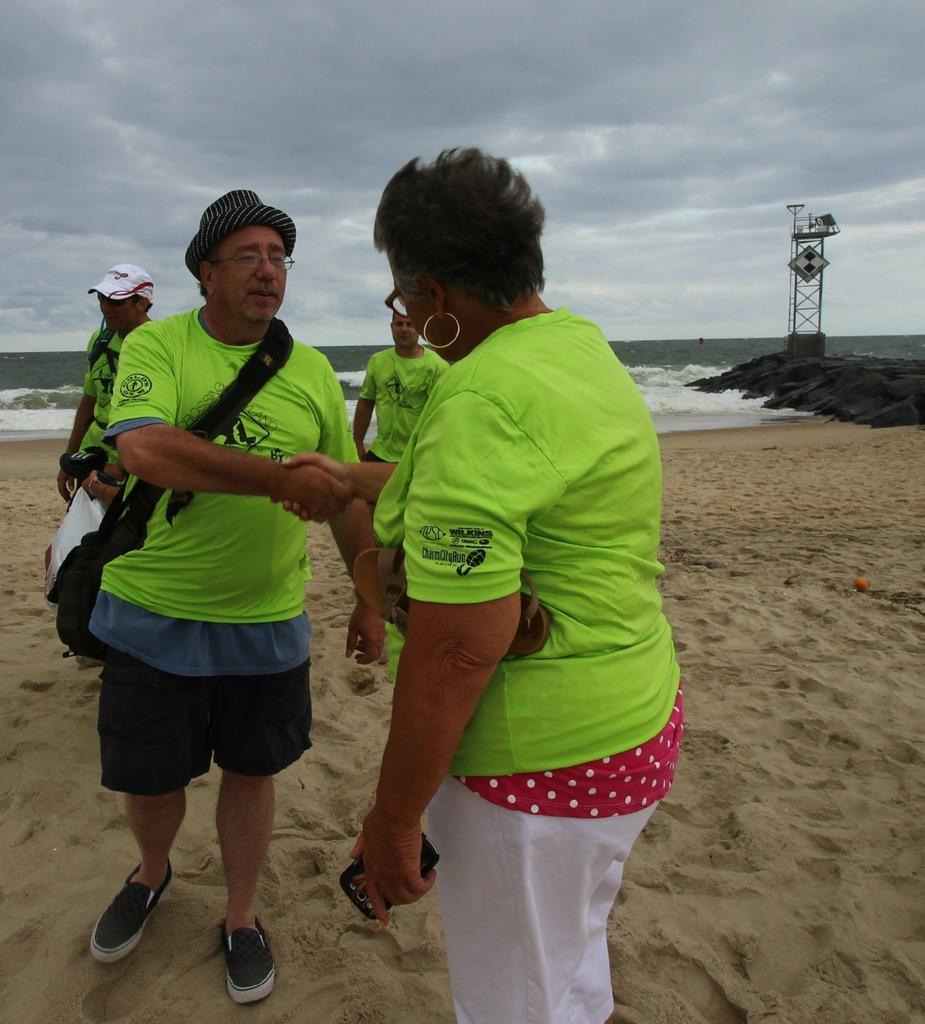Please provide a concise description of this image. In this image we can see some group of persons wearing similar color dress standing at the seashore some are holding objects and some are carrying bags and in the background of the image there is water, tower and top of the image there is cloudy sky. 